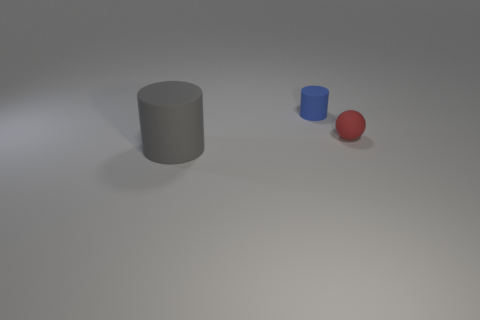How do the textures of these objects compare to one another? The large gray cylinder and the small blue cylinder both have matte surfaces with smooth textures. The red sphere, on the other hand, appears to have a slightly shinier surface, indicating a different texture, perhaps more reflective or rubber-like. 